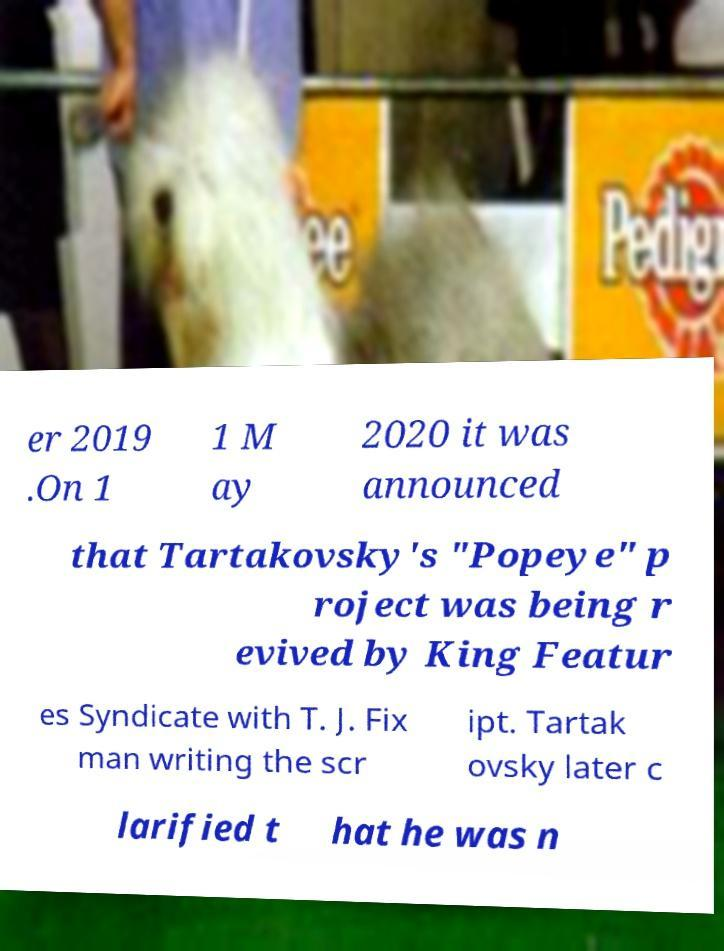Could you extract and type out the text from this image? er 2019 .On 1 1 M ay 2020 it was announced that Tartakovsky's "Popeye" p roject was being r evived by King Featur es Syndicate with T. J. Fix man writing the scr ipt. Tartak ovsky later c larified t hat he was n 